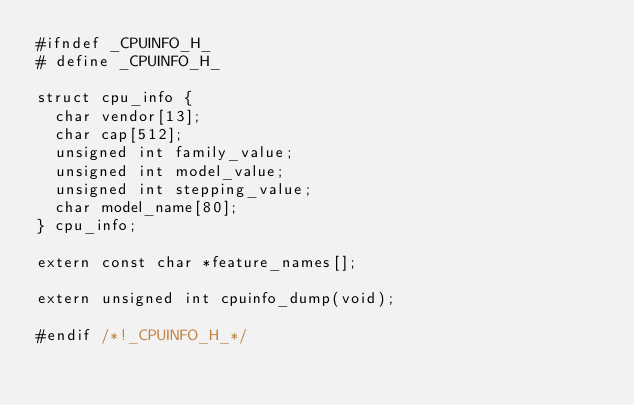Convert code to text. <code><loc_0><loc_0><loc_500><loc_500><_C_>#ifndef _CPUINFO_H_
# define _CPUINFO_H_

struct cpu_info {
	char vendor[13];
	char cap[512];
	unsigned int family_value;
	unsigned int model_value;
	unsigned int stepping_value;
	char model_name[80];
} cpu_info;

extern const char *feature_names[];

extern unsigned int cpuinfo_dump(void);

#endif /*!_CPUINFO_H_*/
</code> 